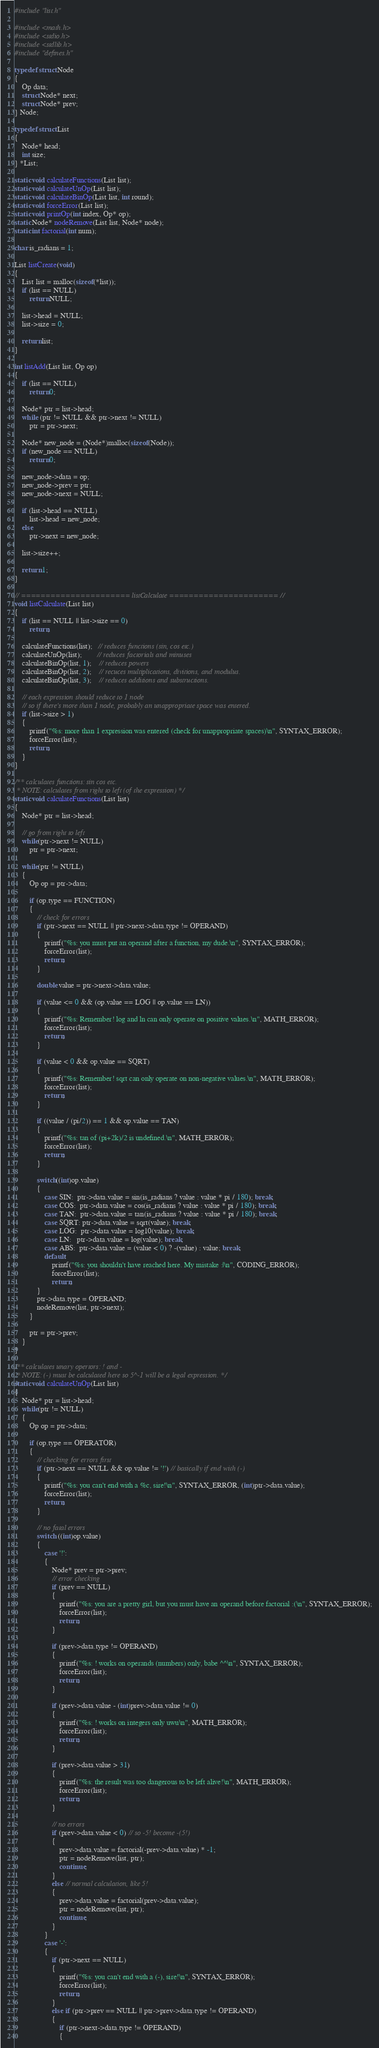Convert code to text. <code><loc_0><loc_0><loc_500><loc_500><_C_>#include "list.h"

#include <math.h>
#include <stdio.h>
#include <stdlib.h>
#include "defines.h"

typedef struct Node
{
    Op data;
    struct Node* next;
    struct Node* prev;
} Node;

typedef struct List
{
    Node* head;
    int size;
} *List;

static void calculateFunctions(List list);
static void calculateUnOp(List list);
static void calculateBinOp(List list, int round);
static void forceError(List list);
static void printOp(int index, Op* op);
static Node* nodeRemove(List list, Node* node);
static int factorial(int num);

char is_radians = 1;

List listCreate(void)
{
    List list = malloc(sizeof(*list));
    if (list == NULL)
        return NULL;
    
    list->head = NULL;
    list->size = 0;

    return list;
}

int listAdd(List list, Op op)
{
    if (list == NULL)
        return 0;
    
    Node* ptr = list->head;
    while (ptr != NULL && ptr->next != NULL)
        ptr = ptr->next;
    
    Node* new_node = (Node*)malloc(sizeof(Node));
    if (new_node == NULL)
        return 0;

    new_node->data = op;
    new_node->prev = ptr;
    new_node->next = NULL;

    if (list->head == NULL)
        list->head = new_node;
    else
        ptr->next = new_node;

    list->size++;

    return 1;
}

// ====================== listCalculate ====================== //
void listCalculate(List list)
{
    if (list == NULL || list->size == 0)
        return;

    calculateFunctions(list);   // reduces functions (sin, cos etc.)
    calculateUnOp(list);        // reduces factorials and minuses
    calculateBinOp(list, 1);    // reduces powers
    calculateBinOp(list, 2);    // recuces multiplications, divitions, and modulus.
    calculateBinOp(list, 3);    // reduces additions and substructions.

    // each expression should reduce to 1 node
    // so if there's more than 1 node, probably an unappropriate space was entered.
    if (list->size > 1)
    {
        printf("%s: more than 1 expression was entered (check for unappropriate spaces)\n", SYNTAX_ERROR);
        forceError(list);
        return;
    }
}

/** calculates functions: sin cos etc.
 * NOTE: calculates from right to left (of the expression) */
static void calculateFunctions(List list)
{
    Node* ptr = list->head;

    // go from right to left
    while(ptr->next != NULL)
        ptr = ptr->next;
    
    while(ptr != NULL)
    {
        Op op = ptr->data;

        if (op.type == FUNCTION)
        {
            // check for errors
            if (ptr->next == NULL || ptr->next->data.type != OPERAND)
            {
                printf("%s: you must put an operand after a function, my dude.\n", SYNTAX_ERROR);
                forceError(list);
                return;
            }

            double value = ptr->next->data.value;

            if (value <= 0 && (op.value == LOG || op.value == LN))
            {
                printf("%s: Remember! log and ln can only operate on positive values.\n", MATH_ERROR);
                forceError(list);
                return;
            }
            
            if (value < 0 && op.value == SQRT)
            {
                printf("%s: Remember! sqrt can only operate on non-negative values.\n", MATH_ERROR);
                forceError(list);
                return;
            }

            if ((value / (pi/2)) == 1 && op.value == TAN)
            {
                printf("%s: tan of (pi+2k)/2 is undefined.\n", MATH_ERROR);
                forceError(list);
                return;
            }

            switch((int)op.value)
            {
                case SIN:  ptr->data.value = sin(is_radians ? value : value * pi / 180); break;
                case COS:  ptr->data.value = cos(is_radians ? value : value * pi / 180); break;
                case TAN:  ptr->data.value = tan(is_radians ? value : value * pi / 180); break;
                case SQRT: ptr->data.value = sqrt(value); break;
                case LOG:  ptr->data.value = log10(value); break;
                case LN:   ptr->data.value = log(value); break;
                case ABS:  ptr->data.value = (value < 0) ? -(value) : value; break;           
                default:
                    printf("%s: you shouldn't have reached here. My mistake :|\n", CODING_ERROR);
                    forceError(list);
                    return;
            }
            ptr->data.type = OPERAND;
            nodeRemove(list, ptr->next);
        }

        ptr = ptr->prev;
    }
}

/** calculates unary opertors: ! and -
 * NOTE: (-) must be calculated here so 5^-1 will be a legal expression. */
static void calculateUnOp(List list)
{
    Node* ptr = list->head;
    while(ptr != NULL)
    {
        Op op = ptr->data;

        if (op.type == OPERATOR)
        {
            // checking for errors first
            if (ptr->next == NULL && op.value != '!') // basically if end with (-)
            {
                printf("%s: you can't end with a %c, sire!\n", SYNTAX_ERROR, (int)ptr->data.value);
                forceError(list);
                return;
            }

            // no fatal errors
            switch ((int)op.value)
            {
                case '!':
                {
                    Node* prev = ptr->prev;
                    // error checking
                    if (prev == NULL)
                    {
                        printf("%s: you are a pretty girl, but you must have an operand before factorial :(\n", SYNTAX_ERROR);
                        forceError(list);
                        return;
                    }

                    if (prev->data.type != OPERAND)
                    {
                        printf("%s: ! works on operands (numbers) only, babe ^^\n", SYNTAX_ERROR);
                        forceError(list);
                        return;
                    }

                    if (prev->data.value - (int)prev->data.value != 0)
                    {
                        printf("%s: ! works on integers only uwu\n", MATH_ERROR);
                        forceError(list);
                        return;
                    }

                    if (prev->data.value > 31)
                    {
                        printf("%s: the result was too dangerous to be left alive!\n", MATH_ERROR);
                        forceError(list);
                        return;
                    }

                    // no errors
                    if (prev->data.value < 0) // so -5! become -(5!)
                    {
                        prev->data.value = factorial(-prev->data.value) * -1;
                        ptr = nodeRemove(list, ptr);
                        continue;
                    }
                    else // normal calculation, like 5!
                    {
                        prev->data.value = factorial(prev->data.value);
                        ptr = nodeRemove(list, ptr);
                        continue;
                    }
                }
                case '-':
                {
                    if (ptr->next == NULL)
                    {
                        printf("%s: you can't end with a (-), sire!\n", SYNTAX_ERROR);
                        forceError(list);
                        return;
                    }
                    else if (ptr->prev == NULL || ptr->prev->data.type != OPERAND)
                    {
                        if (ptr->next->data.type != OPERAND)
                        {</code> 